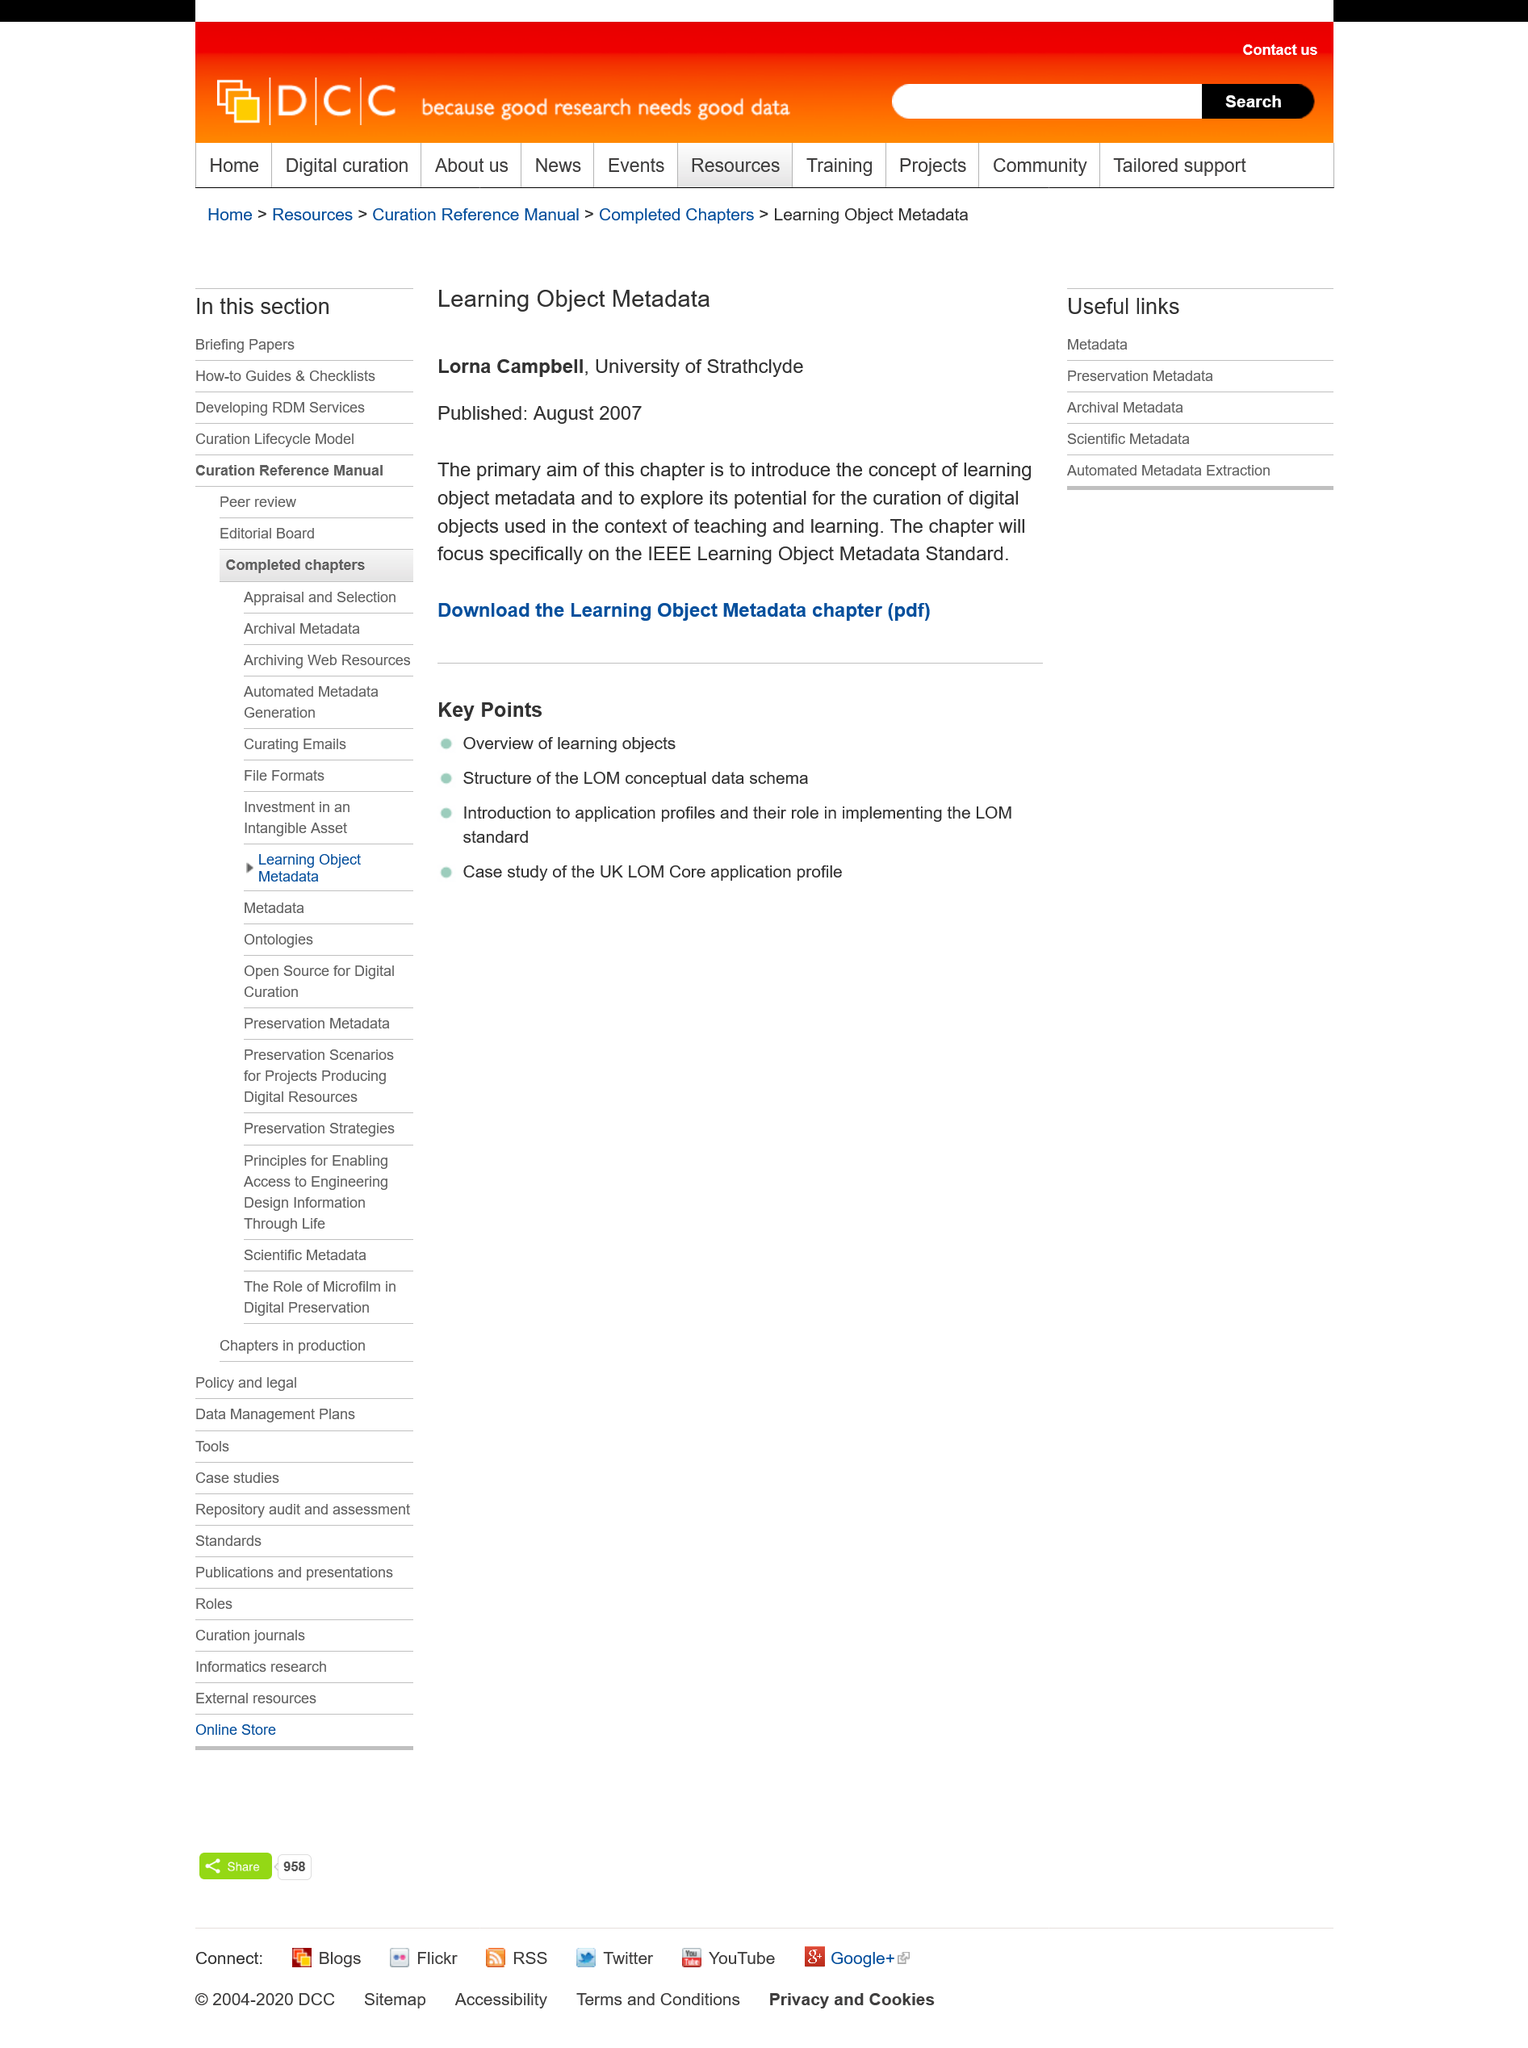Indicate a few pertinent items in this graphic. The primary aim of this chapter is to declare the concept of learning object metadata and to explore its potential for the curation of objects used in the context of teaching and learning. The Learning Object Metadata was published in August 2007. The IEEE Learning Object Metadata Standard will be the primary focus of this chapter. 